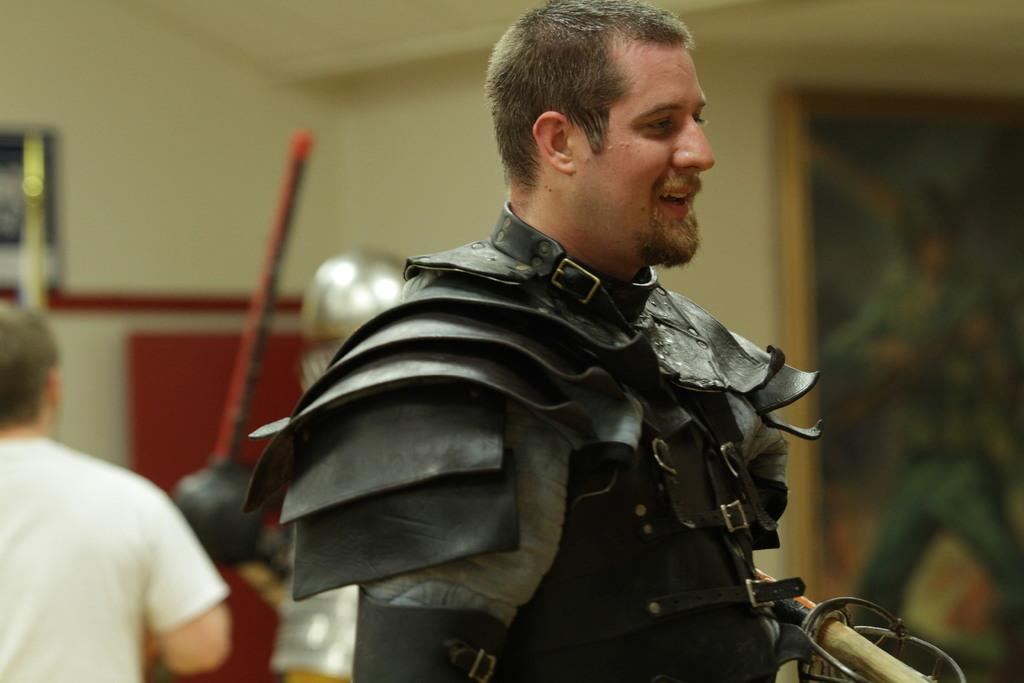How many people are in costumes in the image? There are two persons in costumes in the image. How many people are present in the image in total? There is one person in the image, in addition to the two persons in costumes. What can be seen in the background of the image? There is a wall in the background of the image, and wall paintings are present on the wall. Where might the image have been taken? The image may have been taken in a hall, based on the presence of a wall and wall paintings. What type of cork can be seen on the person's collar in the image? There is no cork present on any person's collar in the image. What color is the vest worn by the person in the image? There is no vest visible in the image; the persons are in costumes, not wearing separate clothing items like vests. 